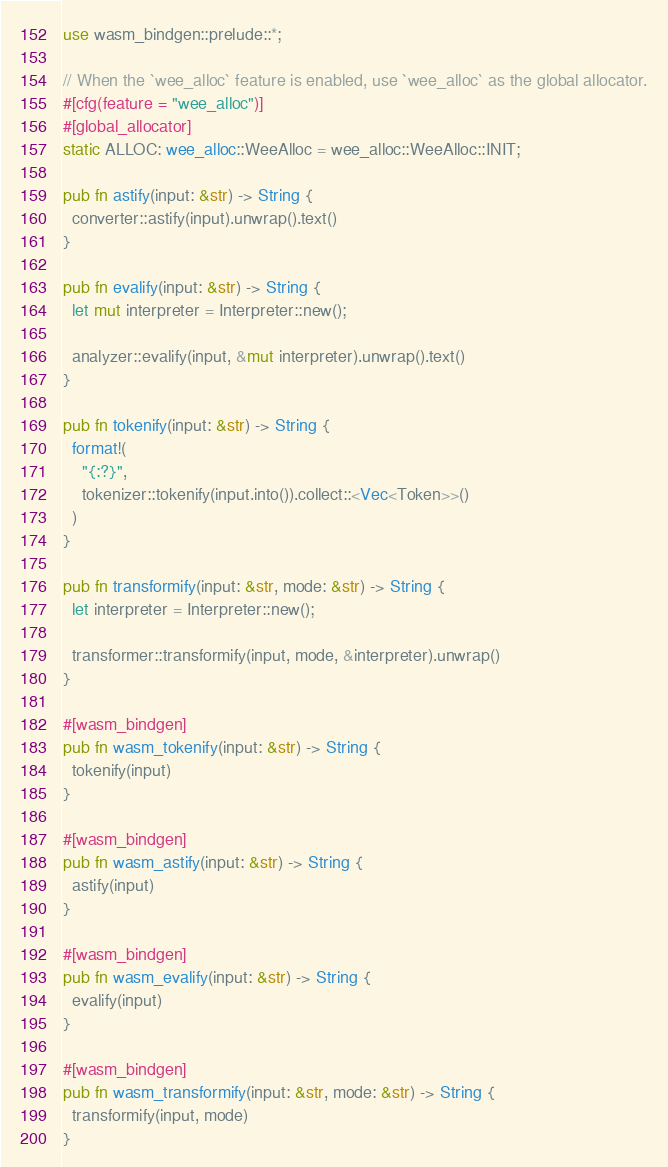Convert code to text. <code><loc_0><loc_0><loc_500><loc_500><_Rust_>
use wasm_bindgen::prelude::*;

// When the `wee_alloc` feature is enabled, use `wee_alloc` as the global allocator.
#[cfg(feature = "wee_alloc")]
#[global_allocator]
static ALLOC: wee_alloc::WeeAlloc = wee_alloc::WeeAlloc::INIT;

pub fn astify(input: &str) -> String {
  converter::astify(input).unwrap().text()
}

pub fn evalify(input: &str) -> String {
  let mut interpreter = Interpreter::new();

  analyzer::evalify(input, &mut interpreter).unwrap().text()
}

pub fn tokenify(input: &str) -> String {
  format!(
    "{:?}",
    tokenizer::tokenify(input.into()).collect::<Vec<Token>>()
  )
}

pub fn transformify(input: &str, mode: &str) -> String {
  let interpreter = Interpreter::new();

  transformer::transformify(input, mode, &interpreter).unwrap()
}

#[wasm_bindgen]
pub fn wasm_tokenify(input: &str) -> String {
  tokenify(input)
}

#[wasm_bindgen]
pub fn wasm_astify(input: &str) -> String {
  astify(input)
}

#[wasm_bindgen]
pub fn wasm_evalify(input: &str) -> String {
  evalify(input)
}

#[wasm_bindgen]
pub fn wasm_transformify(input: &str, mode: &str) -> String {
  transformify(input, mode)
}
</code> 